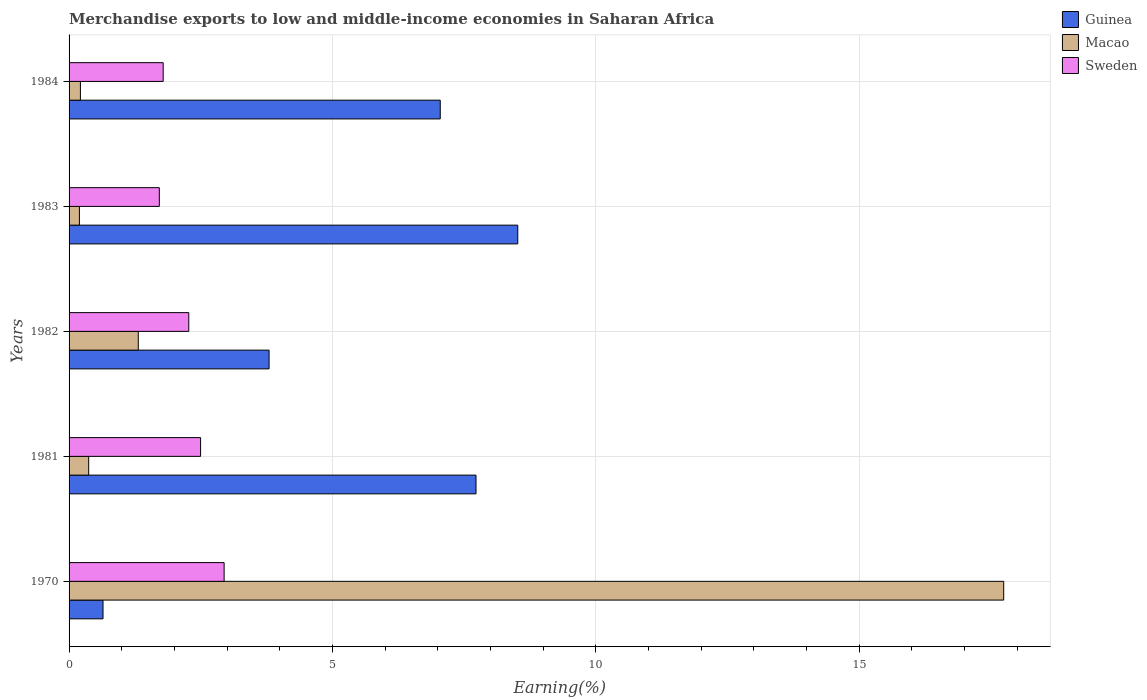How many different coloured bars are there?
Offer a terse response. 3. How many groups of bars are there?
Offer a very short reply. 5. How many bars are there on the 3rd tick from the bottom?
Keep it short and to the point. 3. In how many cases, is the number of bars for a given year not equal to the number of legend labels?
Keep it short and to the point. 0. What is the percentage of amount earned from merchandise exports in Sweden in 1970?
Offer a terse response. 2.94. Across all years, what is the maximum percentage of amount earned from merchandise exports in Macao?
Provide a short and direct response. 17.74. Across all years, what is the minimum percentage of amount earned from merchandise exports in Macao?
Make the answer very short. 0.2. In which year was the percentage of amount earned from merchandise exports in Guinea minimum?
Your answer should be compact. 1970. What is the total percentage of amount earned from merchandise exports in Guinea in the graph?
Provide a short and direct response. 27.73. What is the difference between the percentage of amount earned from merchandise exports in Macao in 1981 and that in 1982?
Your answer should be compact. -0.94. What is the difference between the percentage of amount earned from merchandise exports in Sweden in 1983 and the percentage of amount earned from merchandise exports in Macao in 1982?
Offer a very short reply. 0.4. What is the average percentage of amount earned from merchandise exports in Guinea per year?
Your response must be concise. 5.55. In the year 1984, what is the difference between the percentage of amount earned from merchandise exports in Sweden and percentage of amount earned from merchandise exports in Guinea?
Ensure brevity in your answer.  -5.26. In how many years, is the percentage of amount earned from merchandise exports in Sweden greater than 15 %?
Provide a succinct answer. 0. What is the ratio of the percentage of amount earned from merchandise exports in Guinea in 1983 to that in 1984?
Offer a terse response. 1.21. Is the difference between the percentage of amount earned from merchandise exports in Sweden in 1970 and 1982 greater than the difference between the percentage of amount earned from merchandise exports in Guinea in 1970 and 1982?
Ensure brevity in your answer.  Yes. What is the difference between the highest and the second highest percentage of amount earned from merchandise exports in Sweden?
Your answer should be compact. 0.45. What is the difference between the highest and the lowest percentage of amount earned from merchandise exports in Macao?
Keep it short and to the point. 17.55. In how many years, is the percentage of amount earned from merchandise exports in Guinea greater than the average percentage of amount earned from merchandise exports in Guinea taken over all years?
Provide a short and direct response. 3. What does the 3rd bar from the top in 1970 represents?
Your response must be concise. Guinea. What does the 3rd bar from the bottom in 1970 represents?
Provide a short and direct response. Sweden. How many bars are there?
Keep it short and to the point. 15. Are all the bars in the graph horizontal?
Keep it short and to the point. Yes. How many years are there in the graph?
Offer a terse response. 5. What is the difference between two consecutive major ticks on the X-axis?
Provide a short and direct response. 5. Are the values on the major ticks of X-axis written in scientific E-notation?
Offer a very short reply. No. Does the graph contain grids?
Keep it short and to the point. Yes. Where does the legend appear in the graph?
Offer a very short reply. Top right. What is the title of the graph?
Ensure brevity in your answer.  Merchandise exports to low and middle-income economies in Saharan Africa. Does "Uzbekistan" appear as one of the legend labels in the graph?
Offer a very short reply. No. What is the label or title of the X-axis?
Keep it short and to the point. Earning(%). What is the Earning(%) in Guinea in 1970?
Offer a very short reply. 0.64. What is the Earning(%) in Macao in 1970?
Your answer should be very brief. 17.74. What is the Earning(%) of Sweden in 1970?
Offer a very short reply. 2.94. What is the Earning(%) in Guinea in 1981?
Give a very brief answer. 7.73. What is the Earning(%) of Macao in 1981?
Your response must be concise. 0.37. What is the Earning(%) in Sweden in 1981?
Make the answer very short. 2.5. What is the Earning(%) of Guinea in 1982?
Offer a terse response. 3.8. What is the Earning(%) of Macao in 1982?
Provide a succinct answer. 1.31. What is the Earning(%) in Sweden in 1982?
Offer a very short reply. 2.27. What is the Earning(%) in Guinea in 1983?
Offer a very short reply. 8.52. What is the Earning(%) in Macao in 1983?
Keep it short and to the point. 0.2. What is the Earning(%) in Sweden in 1983?
Ensure brevity in your answer.  1.71. What is the Earning(%) of Guinea in 1984?
Your answer should be compact. 7.05. What is the Earning(%) in Macao in 1984?
Your answer should be compact. 0.22. What is the Earning(%) of Sweden in 1984?
Your answer should be very brief. 1.79. Across all years, what is the maximum Earning(%) of Guinea?
Provide a short and direct response. 8.52. Across all years, what is the maximum Earning(%) in Macao?
Make the answer very short. 17.74. Across all years, what is the maximum Earning(%) of Sweden?
Offer a terse response. 2.94. Across all years, what is the minimum Earning(%) of Guinea?
Give a very brief answer. 0.64. Across all years, what is the minimum Earning(%) in Macao?
Offer a terse response. 0.2. Across all years, what is the minimum Earning(%) in Sweden?
Your answer should be very brief. 1.71. What is the total Earning(%) of Guinea in the graph?
Keep it short and to the point. 27.73. What is the total Earning(%) of Macao in the graph?
Make the answer very short. 19.84. What is the total Earning(%) in Sweden in the graph?
Give a very brief answer. 11.21. What is the difference between the Earning(%) of Guinea in 1970 and that in 1981?
Offer a terse response. -7.08. What is the difference between the Earning(%) of Macao in 1970 and that in 1981?
Keep it short and to the point. 17.37. What is the difference between the Earning(%) of Sweden in 1970 and that in 1981?
Ensure brevity in your answer.  0.45. What is the difference between the Earning(%) of Guinea in 1970 and that in 1982?
Provide a succinct answer. -3.15. What is the difference between the Earning(%) of Macao in 1970 and that in 1982?
Ensure brevity in your answer.  16.43. What is the difference between the Earning(%) in Sweden in 1970 and that in 1982?
Give a very brief answer. 0.67. What is the difference between the Earning(%) of Guinea in 1970 and that in 1983?
Ensure brevity in your answer.  -7.87. What is the difference between the Earning(%) in Macao in 1970 and that in 1983?
Provide a short and direct response. 17.55. What is the difference between the Earning(%) in Sweden in 1970 and that in 1983?
Ensure brevity in your answer.  1.23. What is the difference between the Earning(%) of Guinea in 1970 and that in 1984?
Your answer should be compact. -6.4. What is the difference between the Earning(%) of Macao in 1970 and that in 1984?
Offer a very short reply. 17.53. What is the difference between the Earning(%) in Sweden in 1970 and that in 1984?
Give a very brief answer. 1.16. What is the difference between the Earning(%) of Guinea in 1981 and that in 1982?
Your response must be concise. 3.93. What is the difference between the Earning(%) in Macao in 1981 and that in 1982?
Your response must be concise. -0.94. What is the difference between the Earning(%) in Sweden in 1981 and that in 1982?
Your response must be concise. 0.22. What is the difference between the Earning(%) of Guinea in 1981 and that in 1983?
Offer a terse response. -0.79. What is the difference between the Earning(%) in Macao in 1981 and that in 1983?
Make the answer very short. 0.18. What is the difference between the Earning(%) of Sweden in 1981 and that in 1983?
Offer a very short reply. 0.78. What is the difference between the Earning(%) of Guinea in 1981 and that in 1984?
Give a very brief answer. 0.68. What is the difference between the Earning(%) of Macao in 1981 and that in 1984?
Provide a succinct answer. 0.16. What is the difference between the Earning(%) in Sweden in 1981 and that in 1984?
Keep it short and to the point. 0.71. What is the difference between the Earning(%) of Guinea in 1982 and that in 1983?
Offer a terse response. -4.72. What is the difference between the Earning(%) in Macao in 1982 and that in 1983?
Provide a short and direct response. 1.12. What is the difference between the Earning(%) in Sweden in 1982 and that in 1983?
Your answer should be compact. 0.56. What is the difference between the Earning(%) of Guinea in 1982 and that in 1984?
Your response must be concise. -3.25. What is the difference between the Earning(%) in Macao in 1982 and that in 1984?
Keep it short and to the point. 1.1. What is the difference between the Earning(%) in Sweden in 1982 and that in 1984?
Your answer should be compact. 0.49. What is the difference between the Earning(%) of Guinea in 1983 and that in 1984?
Your answer should be very brief. 1.47. What is the difference between the Earning(%) in Macao in 1983 and that in 1984?
Offer a terse response. -0.02. What is the difference between the Earning(%) of Sweden in 1983 and that in 1984?
Your answer should be compact. -0.07. What is the difference between the Earning(%) of Guinea in 1970 and the Earning(%) of Macao in 1981?
Offer a very short reply. 0.27. What is the difference between the Earning(%) in Guinea in 1970 and the Earning(%) in Sweden in 1981?
Your response must be concise. -1.85. What is the difference between the Earning(%) in Macao in 1970 and the Earning(%) in Sweden in 1981?
Ensure brevity in your answer.  15.25. What is the difference between the Earning(%) in Guinea in 1970 and the Earning(%) in Macao in 1982?
Your answer should be very brief. -0.67. What is the difference between the Earning(%) of Guinea in 1970 and the Earning(%) of Sweden in 1982?
Your answer should be very brief. -1.63. What is the difference between the Earning(%) in Macao in 1970 and the Earning(%) in Sweden in 1982?
Your answer should be very brief. 15.47. What is the difference between the Earning(%) of Guinea in 1970 and the Earning(%) of Macao in 1983?
Offer a very short reply. 0.45. What is the difference between the Earning(%) in Guinea in 1970 and the Earning(%) in Sweden in 1983?
Make the answer very short. -1.07. What is the difference between the Earning(%) of Macao in 1970 and the Earning(%) of Sweden in 1983?
Provide a succinct answer. 16.03. What is the difference between the Earning(%) of Guinea in 1970 and the Earning(%) of Macao in 1984?
Your answer should be very brief. 0.43. What is the difference between the Earning(%) of Guinea in 1970 and the Earning(%) of Sweden in 1984?
Make the answer very short. -1.14. What is the difference between the Earning(%) of Macao in 1970 and the Earning(%) of Sweden in 1984?
Make the answer very short. 15.96. What is the difference between the Earning(%) of Guinea in 1981 and the Earning(%) of Macao in 1982?
Give a very brief answer. 6.41. What is the difference between the Earning(%) of Guinea in 1981 and the Earning(%) of Sweden in 1982?
Provide a short and direct response. 5.45. What is the difference between the Earning(%) in Macao in 1981 and the Earning(%) in Sweden in 1982?
Your response must be concise. -1.9. What is the difference between the Earning(%) of Guinea in 1981 and the Earning(%) of Macao in 1983?
Offer a terse response. 7.53. What is the difference between the Earning(%) in Guinea in 1981 and the Earning(%) in Sweden in 1983?
Provide a succinct answer. 6.01. What is the difference between the Earning(%) of Macao in 1981 and the Earning(%) of Sweden in 1983?
Offer a very short reply. -1.34. What is the difference between the Earning(%) in Guinea in 1981 and the Earning(%) in Macao in 1984?
Offer a very short reply. 7.51. What is the difference between the Earning(%) in Guinea in 1981 and the Earning(%) in Sweden in 1984?
Make the answer very short. 5.94. What is the difference between the Earning(%) of Macao in 1981 and the Earning(%) of Sweden in 1984?
Give a very brief answer. -1.41. What is the difference between the Earning(%) of Guinea in 1982 and the Earning(%) of Macao in 1983?
Your answer should be compact. 3.6. What is the difference between the Earning(%) of Guinea in 1982 and the Earning(%) of Sweden in 1983?
Your response must be concise. 2.08. What is the difference between the Earning(%) in Macao in 1982 and the Earning(%) in Sweden in 1983?
Your answer should be very brief. -0.4. What is the difference between the Earning(%) of Guinea in 1982 and the Earning(%) of Macao in 1984?
Give a very brief answer. 3.58. What is the difference between the Earning(%) of Guinea in 1982 and the Earning(%) of Sweden in 1984?
Offer a terse response. 2.01. What is the difference between the Earning(%) of Macao in 1982 and the Earning(%) of Sweden in 1984?
Offer a terse response. -0.47. What is the difference between the Earning(%) in Guinea in 1983 and the Earning(%) in Macao in 1984?
Provide a short and direct response. 8.3. What is the difference between the Earning(%) in Guinea in 1983 and the Earning(%) in Sweden in 1984?
Your response must be concise. 6.73. What is the difference between the Earning(%) in Macao in 1983 and the Earning(%) in Sweden in 1984?
Keep it short and to the point. -1.59. What is the average Earning(%) of Guinea per year?
Your answer should be compact. 5.55. What is the average Earning(%) in Macao per year?
Provide a succinct answer. 3.97. What is the average Earning(%) in Sweden per year?
Provide a succinct answer. 2.24. In the year 1970, what is the difference between the Earning(%) in Guinea and Earning(%) in Macao?
Keep it short and to the point. -17.1. In the year 1970, what is the difference between the Earning(%) of Guinea and Earning(%) of Sweden?
Keep it short and to the point. -2.3. In the year 1970, what is the difference between the Earning(%) of Macao and Earning(%) of Sweden?
Your response must be concise. 14.8. In the year 1981, what is the difference between the Earning(%) of Guinea and Earning(%) of Macao?
Your answer should be very brief. 7.35. In the year 1981, what is the difference between the Earning(%) in Guinea and Earning(%) in Sweden?
Make the answer very short. 5.23. In the year 1981, what is the difference between the Earning(%) in Macao and Earning(%) in Sweden?
Your answer should be very brief. -2.12. In the year 1982, what is the difference between the Earning(%) of Guinea and Earning(%) of Macao?
Your answer should be very brief. 2.48. In the year 1982, what is the difference between the Earning(%) in Guinea and Earning(%) in Sweden?
Your answer should be compact. 1.52. In the year 1982, what is the difference between the Earning(%) of Macao and Earning(%) of Sweden?
Your response must be concise. -0.96. In the year 1983, what is the difference between the Earning(%) in Guinea and Earning(%) in Macao?
Offer a terse response. 8.32. In the year 1983, what is the difference between the Earning(%) of Guinea and Earning(%) of Sweden?
Offer a very short reply. 6.8. In the year 1983, what is the difference between the Earning(%) of Macao and Earning(%) of Sweden?
Your answer should be compact. -1.52. In the year 1984, what is the difference between the Earning(%) of Guinea and Earning(%) of Macao?
Make the answer very short. 6.83. In the year 1984, what is the difference between the Earning(%) of Guinea and Earning(%) of Sweden?
Keep it short and to the point. 5.26. In the year 1984, what is the difference between the Earning(%) in Macao and Earning(%) in Sweden?
Your answer should be very brief. -1.57. What is the ratio of the Earning(%) in Guinea in 1970 to that in 1981?
Give a very brief answer. 0.08. What is the ratio of the Earning(%) of Macao in 1970 to that in 1981?
Offer a very short reply. 47.66. What is the ratio of the Earning(%) of Sweden in 1970 to that in 1981?
Provide a short and direct response. 1.18. What is the ratio of the Earning(%) of Guinea in 1970 to that in 1982?
Provide a short and direct response. 0.17. What is the ratio of the Earning(%) in Macao in 1970 to that in 1982?
Keep it short and to the point. 13.5. What is the ratio of the Earning(%) of Sweden in 1970 to that in 1982?
Offer a very short reply. 1.3. What is the ratio of the Earning(%) of Guinea in 1970 to that in 1983?
Ensure brevity in your answer.  0.08. What is the ratio of the Earning(%) of Macao in 1970 to that in 1983?
Your answer should be very brief. 90.4. What is the ratio of the Earning(%) of Sweden in 1970 to that in 1983?
Keep it short and to the point. 1.72. What is the ratio of the Earning(%) in Guinea in 1970 to that in 1984?
Give a very brief answer. 0.09. What is the ratio of the Earning(%) in Macao in 1970 to that in 1984?
Provide a succinct answer. 82.47. What is the ratio of the Earning(%) in Sweden in 1970 to that in 1984?
Give a very brief answer. 1.65. What is the ratio of the Earning(%) of Guinea in 1981 to that in 1982?
Provide a short and direct response. 2.03. What is the ratio of the Earning(%) in Macao in 1981 to that in 1982?
Offer a very short reply. 0.28. What is the ratio of the Earning(%) of Sweden in 1981 to that in 1982?
Your answer should be very brief. 1.1. What is the ratio of the Earning(%) in Guinea in 1981 to that in 1983?
Your answer should be compact. 0.91. What is the ratio of the Earning(%) in Macao in 1981 to that in 1983?
Your response must be concise. 1.9. What is the ratio of the Earning(%) in Sweden in 1981 to that in 1983?
Your answer should be very brief. 1.46. What is the ratio of the Earning(%) of Guinea in 1981 to that in 1984?
Your answer should be compact. 1.1. What is the ratio of the Earning(%) of Macao in 1981 to that in 1984?
Ensure brevity in your answer.  1.73. What is the ratio of the Earning(%) in Sweden in 1981 to that in 1984?
Make the answer very short. 1.4. What is the ratio of the Earning(%) in Guinea in 1982 to that in 1983?
Ensure brevity in your answer.  0.45. What is the ratio of the Earning(%) of Macao in 1982 to that in 1983?
Ensure brevity in your answer.  6.7. What is the ratio of the Earning(%) in Sweden in 1982 to that in 1983?
Make the answer very short. 1.33. What is the ratio of the Earning(%) of Guinea in 1982 to that in 1984?
Your response must be concise. 0.54. What is the ratio of the Earning(%) of Macao in 1982 to that in 1984?
Provide a succinct answer. 6.11. What is the ratio of the Earning(%) in Sweden in 1982 to that in 1984?
Offer a terse response. 1.27. What is the ratio of the Earning(%) in Guinea in 1983 to that in 1984?
Keep it short and to the point. 1.21. What is the ratio of the Earning(%) in Macao in 1983 to that in 1984?
Keep it short and to the point. 0.91. What is the ratio of the Earning(%) of Sweden in 1983 to that in 1984?
Your response must be concise. 0.96. What is the difference between the highest and the second highest Earning(%) of Guinea?
Give a very brief answer. 0.79. What is the difference between the highest and the second highest Earning(%) in Macao?
Your answer should be compact. 16.43. What is the difference between the highest and the second highest Earning(%) in Sweden?
Give a very brief answer. 0.45. What is the difference between the highest and the lowest Earning(%) of Guinea?
Provide a short and direct response. 7.87. What is the difference between the highest and the lowest Earning(%) of Macao?
Your answer should be compact. 17.55. What is the difference between the highest and the lowest Earning(%) in Sweden?
Give a very brief answer. 1.23. 